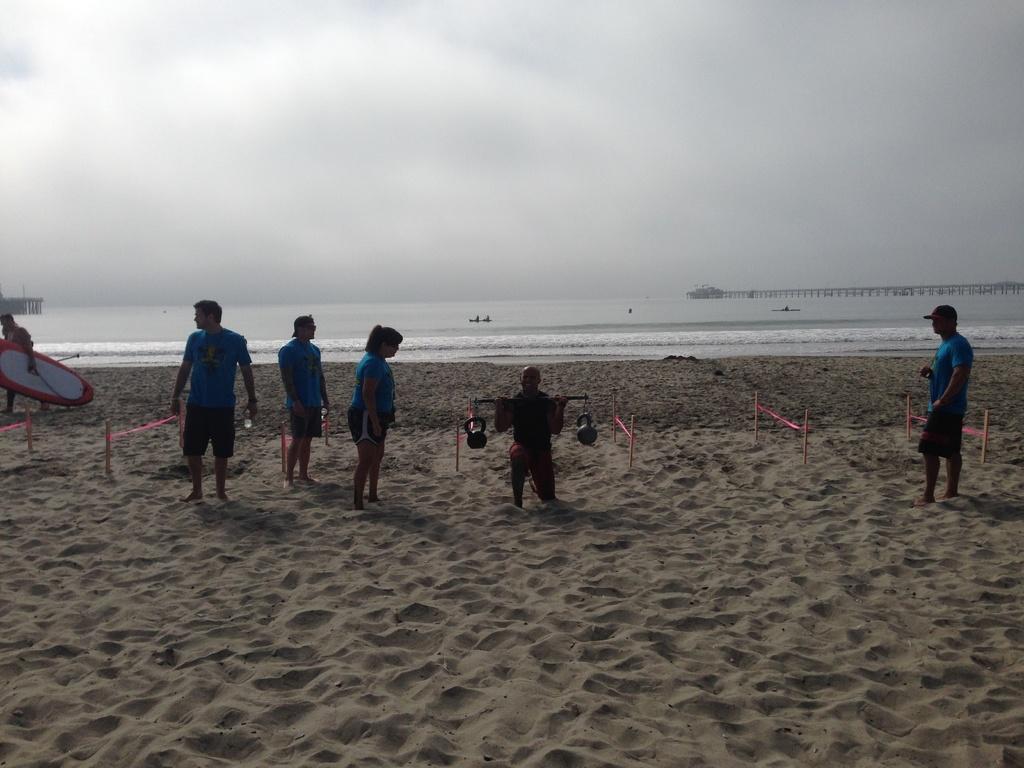Describe this image in one or two sentences. In the image we can see there are people standing. This is a sand, water and sky. This person is lifting the weight. 